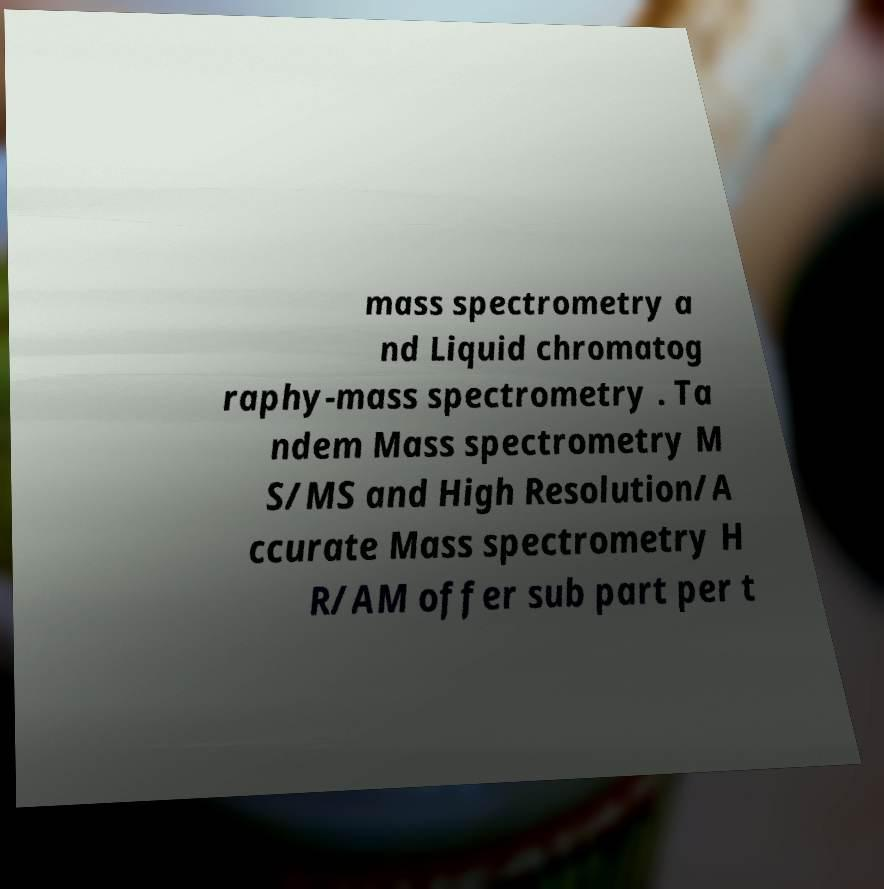Please read and relay the text visible in this image. What does it say? mass spectrometry a nd Liquid chromatog raphy-mass spectrometry . Ta ndem Mass spectrometry M S/MS and High Resolution/A ccurate Mass spectrometry H R/AM offer sub part per t 